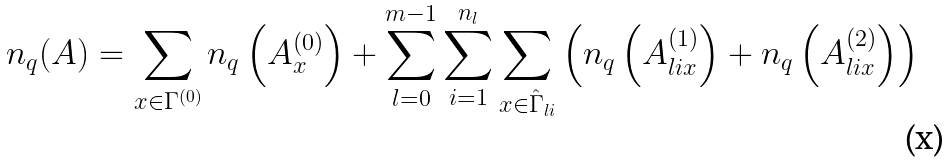Convert formula to latex. <formula><loc_0><loc_0><loc_500><loc_500>n _ { q } ( A ) = \sum _ { x \in \Gamma ^ { ( 0 ) } } n _ { q } \left ( A ^ { ( 0 ) } _ { x } \right ) + \sum _ { l = 0 } ^ { m - 1 } \sum _ { i = 1 } ^ { n _ { l } } \sum _ { x \in \hat { \Gamma } _ { l i } } \left ( n _ { q } \left ( A ^ { ( 1 ) } _ { l i x } \right ) + n _ { q } \left ( A ^ { ( 2 ) } _ { l i x } \right ) \right )</formula> 